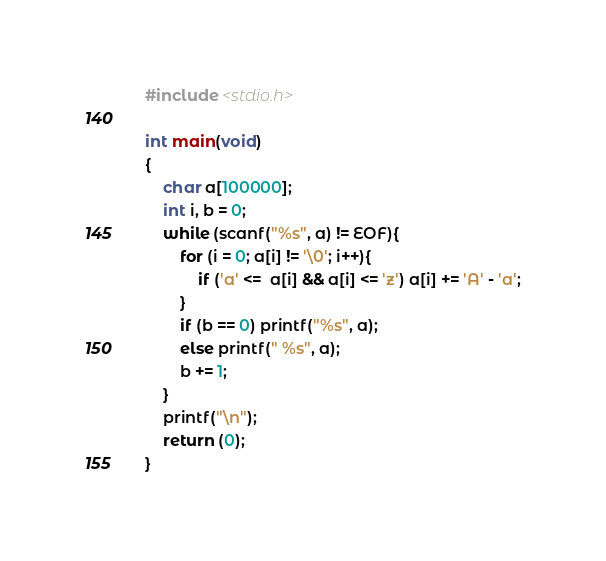<code> <loc_0><loc_0><loc_500><loc_500><_C_>#include <stdio.h>

int main(void)
{
	char a[100000];
	int i, b = 0;
	while (scanf("%s", a) != EOF){
		for (i = 0; a[i] != '\0'; i++){
			if ('a' <=  a[i] && a[i] <= 'z') a[i] += 'A' - 'a';
		}
		if (b == 0) printf("%s", a);
		else printf(" %s", a);
		b += 1;
	}
	printf("\n");
	return (0);
}</code> 